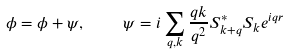<formula> <loc_0><loc_0><loc_500><loc_500>\phi = \phi + \psi , \quad \psi = i \sum _ { q , k } \frac { q k } { q ^ { 2 } } { S ^ { * } _ { k + q } } { S _ { k } } e ^ { i { q r } }</formula> 